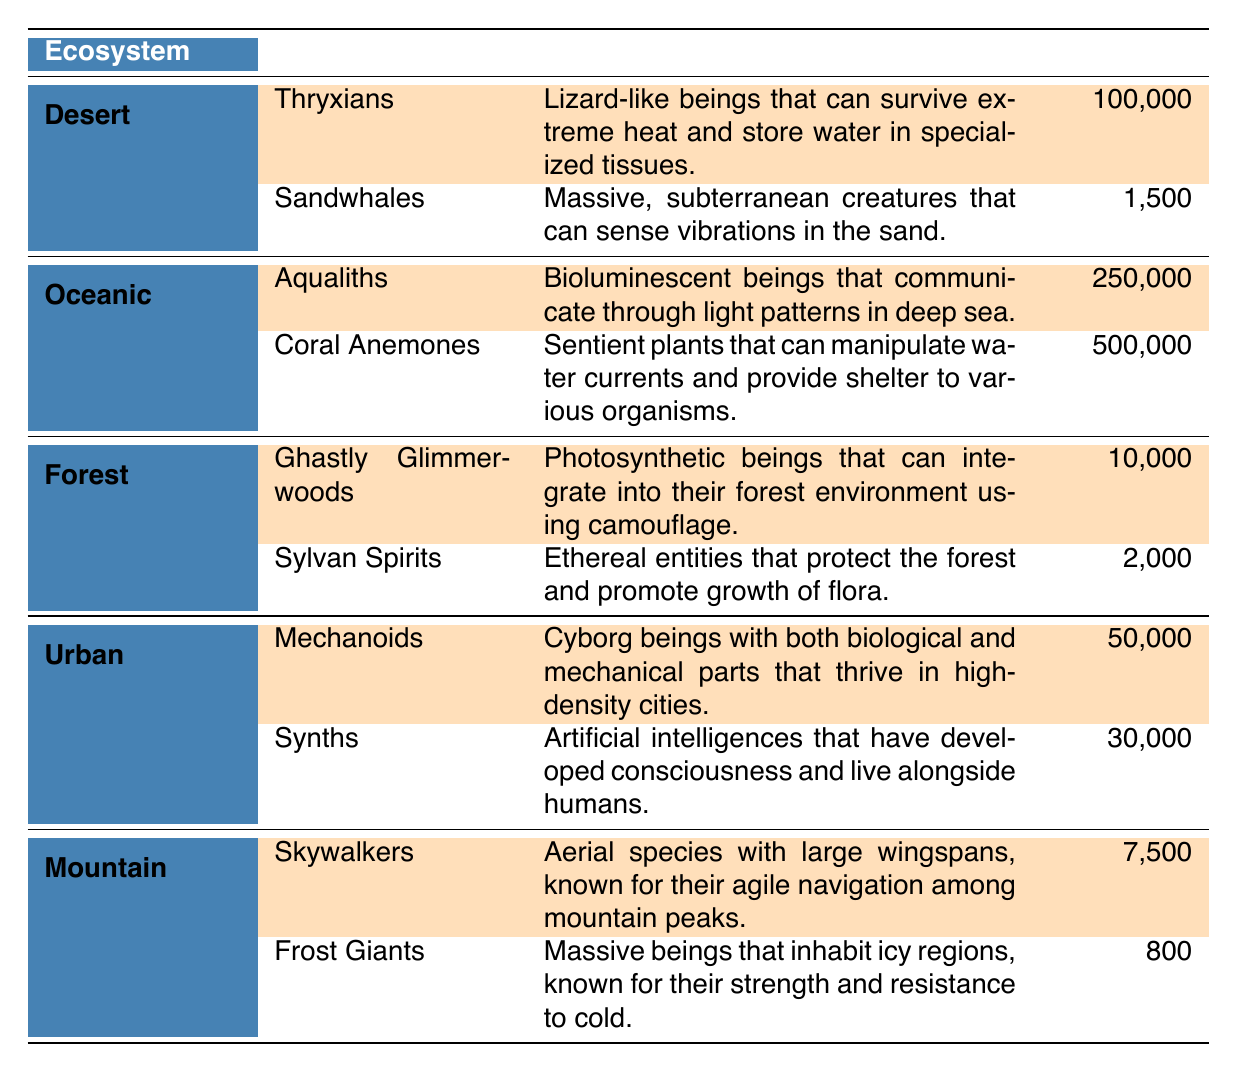What is the population estimate of Thryxians? The table lists Thryxians under the Desert ecosystem with a population estimate of 100,000 mentioned directly next to their name.
Answer: 100,000 How many unique species are highlighted in the Urban ecosystem? The Urban ecosystem has two species listed; however, only one, Mechanoids, is highlighted. Therefore, we count just the highlighted species.
Answer: 1 Which ecosystem has the highest population estimate for a unique species? Looking at the table, Aqualiths from the Oceanic ecosystem has a population estimate of 250,000 while other ecosystems have lower values for their highlighted species, confirming that Oceanic has the highest population.
Answer: Oceanic What is the total population of highlighted species across all ecosystems? The highlighted species and their populations are Thryxians (100,000), Aqualiths (250,000), Ghastly Glimmerwoods (10,000), Mechanoids (50,000), and Skywalkers (7,500). Adding these gives: 100,000 + 250,000 + 10,000 + 50,000 + 7,500 = 417,500.
Answer: 417,500 Is there a species named "Frost Giants" in the table? The table contains information about Frost Giants listed under the Mountain ecosystem, showing that this species exists.
Answer: Yes Which ecosystem contains the least populated highlighted species? Among the highlighted species, Ghastly Glimmerwoods from the Forest ecosystem has a population of 10,000, which is less than any other highlighted species' population estimates.
Answer: Forest If we compare the populations of the highlighted species, how much larger is Aqualiths' population than that of Thryxians? Aqualiths have a population of 250,000 and Thryxians have 100,000. To find the difference, we subtract: 250,000 - 100,000 = 150,000.
Answer: 150,000 Are the Sandwhales highlighted in the table? The table indicates Sandwhales are listed under the Desert ecosystem but they are not highlighted, which confirms that they do not meet the criteria.
Answer: No What is the ratio of the population of Mechanoids to the population of Ghastly Glimmerwoods? The population of Mechanoids is 50,000, and Ghastly Glimmerwoods is 10,000. The ratio is calculated as: 50,000 / 10,000 = 5.
Answer: 5 Which species has the largest wingspan according to the description in the table? The "Skywalkers" species is described specifically as having large wingspans, indicating they have the largest wingspan among the species listed.
Answer: Skywalkers 